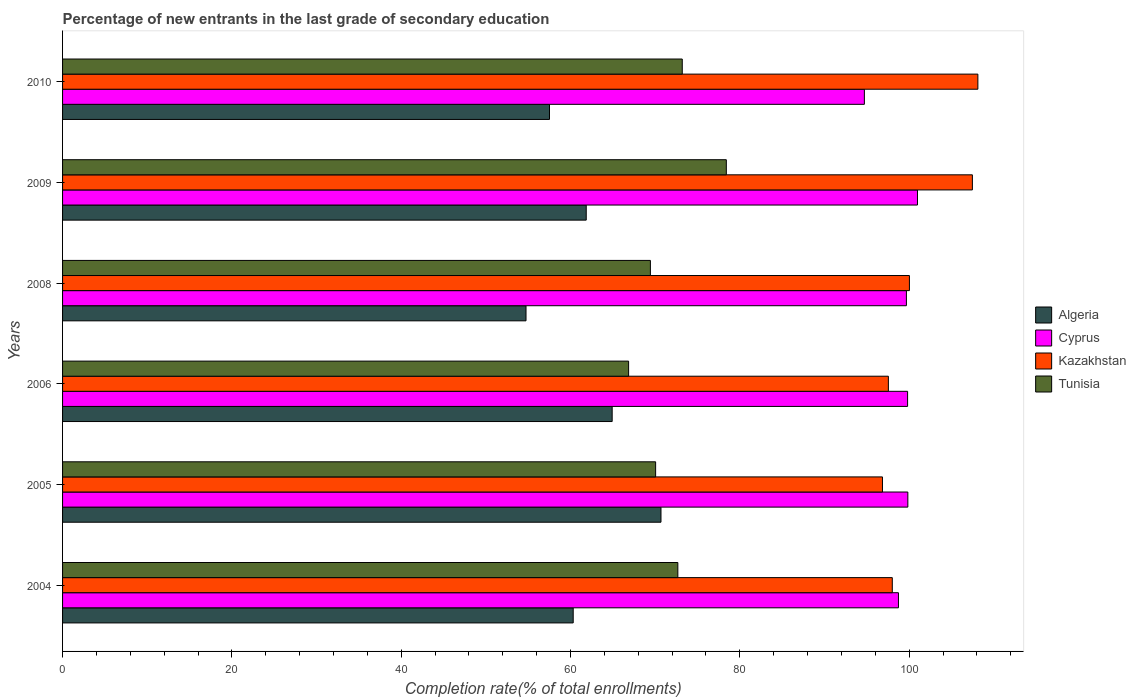How many different coloured bars are there?
Keep it short and to the point. 4. How many groups of bars are there?
Ensure brevity in your answer.  6. How many bars are there on the 6th tick from the top?
Offer a terse response. 4. What is the label of the 2nd group of bars from the top?
Your response must be concise. 2009. In how many cases, is the number of bars for a given year not equal to the number of legend labels?
Give a very brief answer. 0. What is the percentage of new entrants in Tunisia in 2009?
Your response must be concise. 78.41. Across all years, what is the maximum percentage of new entrants in Kazakhstan?
Give a very brief answer. 108.12. Across all years, what is the minimum percentage of new entrants in Kazakhstan?
Offer a terse response. 96.85. In which year was the percentage of new entrants in Kazakhstan maximum?
Ensure brevity in your answer.  2010. In which year was the percentage of new entrants in Tunisia minimum?
Offer a terse response. 2006. What is the total percentage of new entrants in Kazakhstan in the graph?
Your answer should be compact. 608.02. What is the difference between the percentage of new entrants in Algeria in 2005 and that in 2009?
Provide a short and direct response. 8.83. What is the difference between the percentage of new entrants in Tunisia in 2009 and the percentage of new entrants in Algeria in 2008?
Provide a short and direct response. 23.66. What is the average percentage of new entrants in Kazakhstan per year?
Keep it short and to the point. 101.34. In the year 2009, what is the difference between the percentage of new entrants in Kazakhstan and percentage of new entrants in Cyprus?
Provide a short and direct response. 6.49. What is the ratio of the percentage of new entrants in Kazakhstan in 2006 to that in 2010?
Give a very brief answer. 0.9. What is the difference between the highest and the second highest percentage of new entrants in Kazakhstan?
Keep it short and to the point. 0.65. What is the difference between the highest and the lowest percentage of new entrants in Algeria?
Offer a very short reply. 15.94. Is the sum of the percentage of new entrants in Kazakhstan in 2005 and 2009 greater than the maximum percentage of new entrants in Algeria across all years?
Keep it short and to the point. Yes. What does the 2nd bar from the top in 2005 represents?
Give a very brief answer. Kazakhstan. What does the 2nd bar from the bottom in 2004 represents?
Offer a terse response. Cyprus. Is it the case that in every year, the sum of the percentage of new entrants in Cyprus and percentage of new entrants in Algeria is greater than the percentage of new entrants in Tunisia?
Offer a terse response. Yes. How many bars are there?
Give a very brief answer. 24. Are all the bars in the graph horizontal?
Your answer should be compact. Yes. How many years are there in the graph?
Keep it short and to the point. 6. What is the difference between two consecutive major ticks on the X-axis?
Provide a short and direct response. 20. Does the graph contain grids?
Keep it short and to the point. No. How are the legend labels stacked?
Make the answer very short. Vertical. What is the title of the graph?
Offer a terse response. Percentage of new entrants in the last grade of secondary education. What is the label or title of the X-axis?
Keep it short and to the point. Completion rate(% of total enrollments). What is the label or title of the Y-axis?
Your answer should be very brief. Years. What is the Completion rate(% of total enrollments) in Algeria in 2004?
Keep it short and to the point. 60.32. What is the Completion rate(% of total enrollments) of Cyprus in 2004?
Your answer should be very brief. 98.74. What is the Completion rate(% of total enrollments) in Kazakhstan in 2004?
Give a very brief answer. 98.01. What is the Completion rate(% of total enrollments) in Tunisia in 2004?
Give a very brief answer. 72.68. What is the Completion rate(% of total enrollments) in Algeria in 2005?
Provide a short and direct response. 70.69. What is the Completion rate(% of total enrollments) in Cyprus in 2005?
Give a very brief answer. 99.84. What is the Completion rate(% of total enrollments) in Kazakhstan in 2005?
Keep it short and to the point. 96.85. What is the Completion rate(% of total enrollments) of Tunisia in 2005?
Provide a short and direct response. 70.05. What is the Completion rate(% of total enrollments) of Algeria in 2006?
Provide a short and direct response. 64.92. What is the Completion rate(% of total enrollments) of Cyprus in 2006?
Provide a succinct answer. 99.82. What is the Completion rate(% of total enrollments) of Kazakhstan in 2006?
Offer a terse response. 97.55. What is the Completion rate(% of total enrollments) of Tunisia in 2006?
Make the answer very short. 66.86. What is the Completion rate(% of total enrollments) of Algeria in 2008?
Offer a very short reply. 54.74. What is the Completion rate(% of total enrollments) of Cyprus in 2008?
Provide a succinct answer. 99.68. What is the Completion rate(% of total enrollments) of Kazakhstan in 2008?
Keep it short and to the point. 100.03. What is the Completion rate(% of total enrollments) of Tunisia in 2008?
Make the answer very short. 69.44. What is the Completion rate(% of total enrollments) in Algeria in 2009?
Provide a short and direct response. 61.86. What is the Completion rate(% of total enrollments) in Cyprus in 2009?
Provide a short and direct response. 100.98. What is the Completion rate(% of total enrollments) of Kazakhstan in 2009?
Your answer should be compact. 107.47. What is the Completion rate(% of total enrollments) of Tunisia in 2009?
Give a very brief answer. 78.41. What is the Completion rate(% of total enrollments) in Algeria in 2010?
Your answer should be compact. 57.52. What is the Completion rate(% of total enrollments) in Cyprus in 2010?
Your answer should be compact. 94.71. What is the Completion rate(% of total enrollments) in Kazakhstan in 2010?
Offer a terse response. 108.12. What is the Completion rate(% of total enrollments) in Tunisia in 2010?
Your response must be concise. 73.2. Across all years, what is the maximum Completion rate(% of total enrollments) in Algeria?
Offer a very short reply. 70.69. Across all years, what is the maximum Completion rate(% of total enrollments) of Cyprus?
Your response must be concise. 100.98. Across all years, what is the maximum Completion rate(% of total enrollments) in Kazakhstan?
Your answer should be compact. 108.12. Across all years, what is the maximum Completion rate(% of total enrollments) in Tunisia?
Ensure brevity in your answer.  78.41. Across all years, what is the minimum Completion rate(% of total enrollments) of Algeria?
Ensure brevity in your answer.  54.74. Across all years, what is the minimum Completion rate(% of total enrollments) in Cyprus?
Your response must be concise. 94.71. Across all years, what is the minimum Completion rate(% of total enrollments) in Kazakhstan?
Provide a short and direct response. 96.85. Across all years, what is the minimum Completion rate(% of total enrollments) in Tunisia?
Your response must be concise. 66.86. What is the total Completion rate(% of total enrollments) of Algeria in the graph?
Keep it short and to the point. 370.04. What is the total Completion rate(% of total enrollments) in Cyprus in the graph?
Offer a terse response. 593.77. What is the total Completion rate(% of total enrollments) in Kazakhstan in the graph?
Ensure brevity in your answer.  608.02. What is the total Completion rate(% of total enrollments) of Tunisia in the graph?
Your answer should be very brief. 430.63. What is the difference between the Completion rate(% of total enrollments) of Algeria in 2004 and that in 2005?
Offer a terse response. -10.37. What is the difference between the Completion rate(% of total enrollments) in Cyprus in 2004 and that in 2005?
Provide a short and direct response. -1.11. What is the difference between the Completion rate(% of total enrollments) in Kazakhstan in 2004 and that in 2005?
Ensure brevity in your answer.  1.16. What is the difference between the Completion rate(% of total enrollments) of Tunisia in 2004 and that in 2005?
Your response must be concise. 2.63. What is the difference between the Completion rate(% of total enrollments) of Algeria in 2004 and that in 2006?
Your answer should be very brief. -4.6. What is the difference between the Completion rate(% of total enrollments) in Cyprus in 2004 and that in 2006?
Offer a very short reply. -1.08. What is the difference between the Completion rate(% of total enrollments) of Kazakhstan in 2004 and that in 2006?
Ensure brevity in your answer.  0.46. What is the difference between the Completion rate(% of total enrollments) in Tunisia in 2004 and that in 2006?
Give a very brief answer. 5.82. What is the difference between the Completion rate(% of total enrollments) in Algeria in 2004 and that in 2008?
Make the answer very short. 5.57. What is the difference between the Completion rate(% of total enrollments) in Cyprus in 2004 and that in 2008?
Offer a terse response. -0.94. What is the difference between the Completion rate(% of total enrollments) in Kazakhstan in 2004 and that in 2008?
Offer a very short reply. -2.02. What is the difference between the Completion rate(% of total enrollments) of Tunisia in 2004 and that in 2008?
Provide a succinct answer. 3.24. What is the difference between the Completion rate(% of total enrollments) of Algeria in 2004 and that in 2009?
Your response must be concise. -1.54. What is the difference between the Completion rate(% of total enrollments) of Cyprus in 2004 and that in 2009?
Make the answer very short. -2.25. What is the difference between the Completion rate(% of total enrollments) in Kazakhstan in 2004 and that in 2009?
Offer a terse response. -9.46. What is the difference between the Completion rate(% of total enrollments) of Tunisia in 2004 and that in 2009?
Provide a succinct answer. -5.73. What is the difference between the Completion rate(% of total enrollments) of Algeria in 2004 and that in 2010?
Offer a terse response. 2.8. What is the difference between the Completion rate(% of total enrollments) in Cyprus in 2004 and that in 2010?
Give a very brief answer. 4.03. What is the difference between the Completion rate(% of total enrollments) in Kazakhstan in 2004 and that in 2010?
Your answer should be compact. -10.11. What is the difference between the Completion rate(% of total enrollments) in Tunisia in 2004 and that in 2010?
Offer a terse response. -0.52. What is the difference between the Completion rate(% of total enrollments) in Algeria in 2005 and that in 2006?
Provide a short and direct response. 5.76. What is the difference between the Completion rate(% of total enrollments) of Cyprus in 2005 and that in 2006?
Offer a terse response. 0.03. What is the difference between the Completion rate(% of total enrollments) of Kazakhstan in 2005 and that in 2006?
Give a very brief answer. -0.7. What is the difference between the Completion rate(% of total enrollments) of Tunisia in 2005 and that in 2006?
Ensure brevity in your answer.  3.19. What is the difference between the Completion rate(% of total enrollments) in Algeria in 2005 and that in 2008?
Your response must be concise. 15.94. What is the difference between the Completion rate(% of total enrollments) in Cyprus in 2005 and that in 2008?
Make the answer very short. 0.17. What is the difference between the Completion rate(% of total enrollments) in Kazakhstan in 2005 and that in 2008?
Ensure brevity in your answer.  -3.18. What is the difference between the Completion rate(% of total enrollments) in Tunisia in 2005 and that in 2008?
Offer a terse response. 0.62. What is the difference between the Completion rate(% of total enrollments) in Algeria in 2005 and that in 2009?
Offer a terse response. 8.83. What is the difference between the Completion rate(% of total enrollments) of Cyprus in 2005 and that in 2009?
Your answer should be very brief. -1.14. What is the difference between the Completion rate(% of total enrollments) in Kazakhstan in 2005 and that in 2009?
Ensure brevity in your answer.  -10.62. What is the difference between the Completion rate(% of total enrollments) in Tunisia in 2005 and that in 2009?
Keep it short and to the point. -8.35. What is the difference between the Completion rate(% of total enrollments) of Algeria in 2005 and that in 2010?
Give a very brief answer. 13.17. What is the difference between the Completion rate(% of total enrollments) in Cyprus in 2005 and that in 2010?
Keep it short and to the point. 5.13. What is the difference between the Completion rate(% of total enrollments) in Kazakhstan in 2005 and that in 2010?
Provide a short and direct response. -11.27. What is the difference between the Completion rate(% of total enrollments) in Tunisia in 2005 and that in 2010?
Offer a very short reply. -3.15. What is the difference between the Completion rate(% of total enrollments) in Algeria in 2006 and that in 2008?
Your answer should be very brief. 10.18. What is the difference between the Completion rate(% of total enrollments) of Cyprus in 2006 and that in 2008?
Make the answer very short. 0.14. What is the difference between the Completion rate(% of total enrollments) in Kazakhstan in 2006 and that in 2008?
Provide a succinct answer. -2.49. What is the difference between the Completion rate(% of total enrollments) in Tunisia in 2006 and that in 2008?
Your answer should be very brief. -2.57. What is the difference between the Completion rate(% of total enrollments) of Algeria in 2006 and that in 2009?
Keep it short and to the point. 3.06. What is the difference between the Completion rate(% of total enrollments) of Cyprus in 2006 and that in 2009?
Keep it short and to the point. -1.17. What is the difference between the Completion rate(% of total enrollments) of Kazakhstan in 2006 and that in 2009?
Keep it short and to the point. -9.92. What is the difference between the Completion rate(% of total enrollments) in Tunisia in 2006 and that in 2009?
Your response must be concise. -11.54. What is the difference between the Completion rate(% of total enrollments) of Algeria in 2006 and that in 2010?
Offer a terse response. 7.4. What is the difference between the Completion rate(% of total enrollments) in Cyprus in 2006 and that in 2010?
Keep it short and to the point. 5.11. What is the difference between the Completion rate(% of total enrollments) in Kazakhstan in 2006 and that in 2010?
Provide a succinct answer. -10.57. What is the difference between the Completion rate(% of total enrollments) of Tunisia in 2006 and that in 2010?
Give a very brief answer. -6.34. What is the difference between the Completion rate(% of total enrollments) in Algeria in 2008 and that in 2009?
Keep it short and to the point. -7.11. What is the difference between the Completion rate(% of total enrollments) of Cyprus in 2008 and that in 2009?
Offer a terse response. -1.31. What is the difference between the Completion rate(% of total enrollments) in Kazakhstan in 2008 and that in 2009?
Offer a very short reply. -7.44. What is the difference between the Completion rate(% of total enrollments) of Tunisia in 2008 and that in 2009?
Keep it short and to the point. -8.97. What is the difference between the Completion rate(% of total enrollments) in Algeria in 2008 and that in 2010?
Offer a very short reply. -2.77. What is the difference between the Completion rate(% of total enrollments) of Cyprus in 2008 and that in 2010?
Give a very brief answer. 4.96. What is the difference between the Completion rate(% of total enrollments) of Kazakhstan in 2008 and that in 2010?
Your answer should be compact. -8.09. What is the difference between the Completion rate(% of total enrollments) of Tunisia in 2008 and that in 2010?
Your response must be concise. -3.76. What is the difference between the Completion rate(% of total enrollments) in Algeria in 2009 and that in 2010?
Give a very brief answer. 4.34. What is the difference between the Completion rate(% of total enrollments) of Cyprus in 2009 and that in 2010?
Provide a short and direct response. 6.27. What is the difference between the Completion rate(% of total enrollments) of Kazakhstan in 2009 and that in 2010?
Your response must be concise. -0.65. What is the difference between the Completion rate(% of total enrollments) in Tunisia in 2009 and that in 2010?
Make the answer very short. 5.21. What is the difference between the Completion rate(% of total enrollments) in Algeria in 2004 and the Completion rate(% of total enrollments) in Cyprus in 2005?
Provide a succinct answer. -39.53. What is the difference between the Completion rate(% of total enrollments) of Algeria in 2004 and the Completion rate(% of total enrollments) of Kazakhstan in 2005?
Make the answer very short. -36.53. What is the difference between the Completion rate(% of total enrollments) of Algeria in 2004 and the Completion rate(% of total enrollments) of Tunisia in 2005?
Give a very brief answer. -9.74. What is the difference between the Completion rate(% of total enrollments) in Cyprus in 2004 and the Completion rate(% of total enrollments) in Kazakhstan in 2005?
Ensure brevity in your answer.  1.89. What is the difference between the Completion rate(% of total enrollments) of Cyprus in 2004 and the Completion rate(% of total enrollments) of Tunisia in 2005?
Your answer should be compact. 28.68. What is the difference between the Completion rate(% of total enrollments) in Kazakhstan in 2004 and the Completion rate(% of total enrollments) in Tunisia in 2005?
Provide a short and direct response. 27.96. What is the difference between the Completion rate(% of total enrollments) in Algeria in 2004 and the Completion rate(% of total enrollments) in Cyprus in 2006?
Offer a terse response. -39.5. What is the difference between the Completion rate(% of total enrollments) of Algeria in 2004 and the Completion rate(% of total enrollments) of Kazakhstan in 2006?
Make the answer very short. -37.23. What is the difference between the Completion rate(% of total enrollments) in Algeria in 2004 and the Completion rate(% of total enrollments) in Tunisia in 2006?
Offer a terse response. -6.54. What is the difference between the Completion rate(% of total enrollments) of Cyprus in 2004 and the Completion rate(% of total enrollments) of Kazakhstan in 2006?
Give a very brief answer. 1.19. What is the difference between the Completion rate(% of total enrollments) in Cyprus in 2004 and the Completion rate(% of total enrollments) in Tunisia in 2006?
Ensure brevity in your answer.  31.88. What is the difference between the Completion rate(% of total enrollments) of Kazakhstan in 2004 and the Completion rate(% of total enrollments) of Tunisia in 2006?
Your answer should be compact. 31.15. What is the difference between the Completion rate(% of total enrollments) in Algeria in 2004 and the Completion rate(% of total enrollments) in Cyprus in 2008?
Provide a succinct answer. -39.36. What is the difference between the Completion rate(% of total enrollments) of Algeria in 2004 and the Completion rate(% of total enrollments) of Kazakhstan in 2008?
Provide a short and direct response. -39.71. What is the difference between the Completion rate(% of total enrollments) in Algeria in 2004 and the Completion rate(% of total enrollments) in Tunisia in 2008?
Give a very brief answer. -9.12. What is the difference between the Completion rate(% of total enrollments) of Cyprus in 2004 and the Completion rate(% of total enrollments) of Kazakhstan in 2008?
Provide a short and direct response. -1.29. What is the difference between the Completion rate(% of total enrollments) of Cyprus in 2004 and the Completion rate(% of total enrollments) of Tunisia in 2008?
Make the answer very short. 29.3. What is the difference between the Completion rate(% of total enrollments) of Kazakhstan in 2004 and the Completion rate(% of total enrollments) of Tunisia in 2008?
Offer a very short reply. 28.57. What is the difference between the Completion rate(% of total enrollments) in Algeria in 2004 and the Completion rate(% of total enrollments) in Cyprus in 2009?
Your response must be concise. -40.67. What is the difference between the Completion rate(% of total enrollments) in Algeria in 2004 and the Completion rate(% of total enrollments) in Kazakhstan in 2009?
Make the answer very short. -47.15. What is the difference between the Completion rate(% of total enrollments) in Algeria in 2004 and the Completion rate(% of total enrollments) in Tunisia in 2009?
Your answer should be compact. -18.09. What is the difference between the Completion rate(% of total enrollments) in Cyprus in 2004 and the Completion rate(% of total enrollments) in Kazakhstan in 2009?
Give a very brief answer. -8.73. What is the difference between the Completion rate(% of total enrollments) of Cyprus in 2004 and the Completion rate(% of total enrollments) of Tunisia in 2009?
Keep it short and to the point. 20.33. What is the difference between the Completion rate(% of total enrollments) of Kazakhstan in 2004 and the Completion rate(% of total enrollments) of Tunisia in 2009?
Give a very brief answer. 19.6. What is the difference between the Completion rate(% of total enrollments) of Algeria in 2004 and the Completion rate(% of total enrollments) of Cyprus in 2010?
Ensure brevity in your answer.  -34.39. What is the difference between the Completion rate(% of total enrollments) of Algeria in 2004 and the Completion rate(% of total enrollments) of Kazakhstan in 2010?
Provide a short and direct response. -47.8. What is the difference between the Completion rate(% of total enrollments) in Algeria in 2004 and the Completion rate(% of total enrollments) in Tunisia in 2010?
Offer a terse response. -12.88. What is the difference between the Completion rate(% of total enrollments) of Cyprus in 2004 and the Completion rate(% of total enrollments) of Kazakhstan in 2010?
Make the answer very short. -9.38. What is the difference between the Completion rate(% of total enrollments) of Cyprus in 2004 and the Completion rate(% of total enrollments) of Tunisia in 2010?
Offer a very short reply. 25.54. What is the difference between the Completion rate(% of total enrollments) of Kazakhstan in 2004 and the Completion rate(% of total enrollments) of Tunisia in 2010?
Provide a succinct answer. 24.81. What is the difference between the Completion rate(% of total enrollments) in Algeria in 2005 and the Completion rate(% of total enrollments) in Cyprus in 2006?
Ensure brevity in your answer.  -29.13. What is the difference between the Completion rate(% of total enrollments) in Algeria in 2005 and the Completion rate(% of total enrollments) in Kazakhstan in 2006?
Make the answer very short. -26.86. What is the difference between the Completion rate(% of total enrollments) of Algeria in 2005 and the Completion rate(% of total enrollments) of Tunisia in 2006?
Your answer should be very brief. 3.82. What is the difference between the Completion rate(% of total enrollments) of Cyprus in 2005 and the Completion rate(% of total enrollments) of Kazakhstan in 2006?
Provide a short and direct response. 2.3. What is the difference between the Completion rate(% of total enrollments) of Cyprus in 2005 and the Completion rate(% of total enrollments) of Tunisia in 2006?
Your answer should be compact. 32.98. What is the difference between the Completion rate(% of total enrollments) of Kazakhstan in 2005 and the Completion rate(% of total enrollments) of Tunisia in 2006?
Your answer should be compact. 29.99. What is the difference between the Completion rate(% of total enrollments) of Algeria in 2005 and the Completion rate(% of total enrollments) of Cyprus in 2008?
Make the answer very short. -28.99. What is the difference between the Completion rate(% of total enrollments) of Algeria in 2005 and the Completion rate(% of total enrollments) of Kazakhstan in 2008?
Keep it short and to the point. -29.35. What is the difference between the Completion rate(% of total enrollments) of Algeria in 2005 and the Completion rate(% of total enrollments) of Tunisia in 2008?
Make the answer very short. 1.25. What is the difference between the Completion rate(% of total enrollments) in Cyprus in 2005 and the Completion rate(% of total enrollments) in Kazakhstan in 2008?
Offer a terse response. -0.19. What is the difference between the Completion rate(% of total enrollments) of Cyprus in 2005 and the Completion rate(% of total enrollments) of Tunisia in 2008?
Your answer should be compact. 30.41. What is the difference between the Completion rate(% of total enrollments) in Kazakhstan in 2005 and the Completion rate(% of total enrollments) in Tunisia in 2008?
Make the answer very short. 27.41. What is the difference between the Completion rate(% of total enrollments) in Algeria in 2005 and the Completion rate(% of total enrollments) in Cyprus in 2009?
Ensure brevity in your answer.  -30.3. What is the difference between the Completion rate(% of total enrollments) of Algeria in 2005 and the Completion rate(% of total enrollments) of Kazakhstan in 2009?
Make the answer very short. -36.78. What is the difference between the Completion rate(% of total enrollments) of Algeria in 2005 and the Completion rate(% of total enrollments) of Tunisia in 2009?
Offer a terse response. -7.72. What is the difference between the Completion rate(% of total enrollments) in Cyprus in 2005 and the Completion rate(% of total enrollments) in Kazakhstan in 2009?
Provide a short and direct response. -7.62. What is the difference between the Completion rate(% of total enrollments) of Cyprus in 2005 and the Completion rate(% of total enrollments) of Tunisia in 2009?
Give a very brief answer. 21.44. What is the difference between the Completion rate(% of total enrollments) in Kazakhstan in 2005 and the Completion rate(% of total enrollments) in Tunisia in 2009?
Offer a terse response. 18.44. What is the difference between the Completion rate(% of total enrollments) of Algeria in 2005 and the Completion rate(% of total enrollments) of Cyprus in 2010?
Offer a terse response. -24.03. What is the difference between the Completion rate(% of total enrollments) of Algeria in 2005 and the Completion rate(% of total enrollments) of Kazakhstan in 2010?
Keep it short and to the point. -37.43. What is the difference between the Completion rate(% of total enrollments) of Algeria in 2005 and the Completion rate(% of total enrollments) of Tunisia in 2010?
Give a very brief answer. -2.51. What is the difference between the Completion rate(% of total enrollments) of Cyprus in 2005 and the Completion rate(% of total enrollments) of Kazakhstan in 2010?
Keep it short and to the point. -8.27. What is the difference between the Completion rate(% of total enrollments) in Cyprus in 2005 and the Completion rate(% of total enrollments) in Tunisia in 2010?
Your answer should be compact. 26.64. What is the difference between the Completion rate(% of total enrollments) in Kazakhstan in 2005 and the Completion rate(% of total enrollments) in Tunisia in 2010?
Your answer should be compact. 23.65. What is the difference between the Completion rate(% of total enrollments) in Algeria in 2006 and the Completion rate(% of total enrollments) in Cyprus in 2008?
Keep it short and to the point. -34.75. What is the difference between the Completion rate(% of total enrollments) of Algeria in 2006 and the Completion rate(% of total enrollments) of Kazakhstan in 2008?
Ensure brevity in your answer.  -35.11. What is the difference between the Completion rate(% of total enrollments) in Algeria in 2006 and the Completion rate(% of total enrollments) in Tunisia in 2008?
Your answer should be very brief. -4.51. What is the difference between the Completion rate(% of total enrollments) of Cyprus in 2006 and the Completion rate(% of total enrollments) of Kazakhstan in 2008?
Your answer should be very brief. -0.21. What is the difference between the Completion rate(% of total enrollments) in Cyprus in 2006 and the Completion rate(% of total enrollments) in Tunisia in 2008?
Give a very brief answer. 30.38. What is the difference between the Completion rate(% of total enrollments) of Kazakhstan in 2006 and the Completion rate(% of total enrollments) of Tunisia in 2008?
Offer a terse response. 28.11. What is the difference between the Completion rate(% of total enrollments) in Algeria in 2006 and the Completion rate(% of total enrollments) in Cyprus in 2009?
Give a very brief answer. -36.06. What is the difference between the Completion rate(% of total enrollments) in Algeria in 2006 and the Completion rate(% of total enrollments) in Kazakhstan in 2009?
Keep it short and to the point. -42.55. What is the difference between the Completion rate(% of total enrollments) in Algeria in 2006 and the Completion rate(% of total enrollments) in Tunisia in 2009?
Make the answer very short. -13.48. What is the difference between the Completion rate(% of total enrollments) in Cyprus in 2006 and the Completion rate(% of total enrollments) in Kazakhstan in 2009?
Ensure brevity in your answer.  -7.65. What is the difference between the Completion rate(% of total enrollments) in Cyprus in 2006 and the Completion rate(% of total enrollments) in Tunisia in 2009?
Provide a short and direct response. 21.41. What is the difference between the Completion rate(% of total enrollments) in Kazakhstan in 2006 and the Completion rate(% of total enrollments) in Tunisia in 2009?
Your response must be concise. 19.14. What is the difference between the Completion rate(% of total enrollments) of Algeria in 2006 and the Completion rate(% of total enrollments) of Cyprus in 2010?
Ensure brevity in your answer.  -29.79. What is the difference between the Completion rate(% of total enrollments) in Algeria in 2006 and the Completion rate(% of total enrollments) in Kazakhstan in 2010?
Your answer should be very brief. -43.2. What is the difference between the Completion rate(% of total enrollments) in Algeria in 2006 and the Completion rate(% of total enrollments) in Tunisia in 2010?
Make the answer very short. -8.28. What is the difference between the Completion rate(% of total enrollments) of Cyprus in 2006 and the Completion rate(% of total enrollments) of Kazakhstan in 2010?
Keep it short and to the point. -8.3. What is the difference between the Completion rate(% of total enrollments) in Cyprus in 2006 and the Completion rate(% of total enrollments) in Tunisia in 2010?
Your answer should be very brief. 26.62. What is the difference between the Completion rate(% of total enrollments) of Kazakhstan in 2006 and the Completion rate(% of total enrollments) of Tunisia in 2010?
Ensure brevity in your answer.  24.35. What is the difference between the Completion rate(% of total enrollments) of Algeria in 2008 and the Completion rate(% of total enrollments) of Cyprus in 2009?
Offer a very short reply. -46.24. What is the difference between the Completion rate(% of total enrollments) of Algeria in 2008 and the Completion rate(% of total enrollments) of Kazakhstan in 2009?
Offer a terse response. -52.73. What is the difference between the Completion rate(% of total enrollments) of Algeria in 2008 and the Completion rate(% of total enrollments) of Tunisia in 2009?
Your answer should be very brief. -23.66. What is the difference between the Completion rate(% of total enrollments) of Cyprus in 2008 and the Completion rate(% of total enrollments) of Kazakhstan in 2009?
Make the answer very short. -7.79. What is the difference between the Completion rate(% of total enrollments) in Cyprus in 2008 and the Completion rate(% of total enrollments) in Tunisia in 2009?
Provide a succinct answer. 21.27. What is the difference between the Completion rate(% of total enrollments) of Kazakhstan in 2008 and the Completion rate(% of total enrollments) of Tunisia in 2009?
Keep it short and to the point. 21.63. What is the difference between the Completion rate(% of total enrollments) in Algeria in 2008 and the Completion rate(% of total enrollments) in Cyprus in 2010?
Provide a succinct answer. -39.97. What is the difference between the Completion rate(% of total enrollments) of Algeria in 2008 and the Completion rate(% of total enrollments) of Kazakhstan in 2010?
Keep it short and to the point. -53.37. What is the difference between the Completion rate(% of total enrollments) in Algeria in 2008 and the Completion rate(% of total enrollments) in Tunisia in 2010?
Offer a very short reply. -18.46. What is the difference between the Completion rate(% of total enrollments) in Cyprus in 2008 and the Completion rate(% of total enrollments) in Kazakhstan in 2010?
Ensure brevity in your answer.  -8.44. What is the difference between the Completion rate(% of total enrollments) of Cyprus in 2008 and the Completion rate(% of total enrollments) of Tunisia in 2010?
Provide a succinct answer. 26.48. What is the difference between the Completion rate(% of total enrollments) of Kazakhstan in 2008 and the Completion rate(% of total enrollments) of Tunisia in 2010?
Your response must be concise. 26.83. What is the difference between the Completion rate(% of total enrollments) in Algeria in 2009 and the Completion rate(% of total enrollments) in Cyprus in 2010?
Keep it short and to the point. -32.85. What is the difference between the Completion rate(% of total enrollments) of Algeria in 2009 and the Completion rate(% of total enrollments) of Kazakhstan in 2010?
Your response must be concise. -46.26. What is the difference between the Completion rate(% of total enrollments) of Algeria in 2009 and the Completion rate(% of total enrollments) of Tunisia in 2010?
Make the answer very short. -11.34. What is the difference between the Completion rate(% of total enrollments) of Cyprus in 2009 and the Completion rate(% of total enrollments) of Kazakhstan in 2010?
Give a very brief answer. -7.13. What is the difference between the Completion rate(% of total enrollments) in Cyprus in 2009 and the Completion rate(% of total enrollments) in Tunisia in 2010?
Provide a short and direct response. 27.78. What is the difference between the Completion rate(% of total enrollments) of Kazakhstan in 2009 and the Completion rate(% of total enrollments) of Tunisia in 2010?
Your response must be concise. 34.27. What is the average Completion rate(% of total enrollments) in Algeria per year?
Provide a succinct answer. 61.67. What is the average Completion rate(% of total enrollments) in Cyprus per year?
Make the answer very short. 98.96. What is the average Completion rate(% of total enrollments) of Kazakhstan per year?
Ensure brevity in your answer.  101.34. What is the average Completion rate(% of total enrollments) of Tunisia per year?
Ensure brevity in your answer.  71.77. In the year 2004, what is the difference between the Completion rate(% of total enrollments) of Algeria and Completion rate(% of total enrollments) of Cyprus?
Your response must be concise. -38.42. In the year 2004, what is the difference between the Completion rate(% of total enrollments) in Algeria and Completion rate(% of total enrollments) in Kazakhstan?
Ensure brevity in your answer.  -37.69. In the year 2004, what is the difference between the Completion rate(% of total enrollments) of Algeria and Completion rate(% of total enrollments) of Tunisia?
Offer a very short reply. -12.36. In the year 2004, what is the difference between the Completion rate(% of total enrollments) in Cyprus and Completion rate(% of total enrollments) in Kazakhstan?
Provide a short and direct response. 0.73. In the year 2004, what is the difference between the Completion rate(% of total enrollments) of Cyprus and Completion rate(% of total enrollments) of Tunisia?
Your response must be concise. 26.06. In the year 2004, what is the difference between the Completion rate(% of total enrollments) of Kazakhstan and Completion rate(% of total enrollments) of Tunisia?
Make the answer very short. 25.33. In the year 2005, what is the difference between the Completion rate(% of total enrollments) of Algeria and Completion rate(% of total enrollments) of Cyprus?
Offer a very short reply. -29.16. In the year 2005, what is the difference between the Completion rate(% of total enrollments) of Algeria and Completion rate(% of total enrollments) of Kazakhstan?
Make the answer very short. -26.16. In the year 2005, what is the difference between the Completion rate(% of total enrollments) of Algeria and Completion rate(% of total enrollments) of Tunisia?
Your response must be concise. 0.63. In the year 2005, what is the difference between the Completion rate(% of total enrollments) in Cyprus and Completion rate(% of total enrollments) in Kazakhstan?
Keep it short and to the point. 3. In the year 2005, what is the difference between the Completion rate(% of total enrollments) in Cyprus and Completion rate(% of total enrollments) in Tunisia?
Provide a short and direct response. 29.79. In the year 2005, what is the difference between the Completion rate(% of total enrollments) in Kazakhstan and Completion rate(% of total enrollments) in Tunisia?
Your response must be concise. 26.8. In the year 2006, what is the difference between the Completion rate(% of total enrollments) of Algeria and Completion rate(% of total enrollments) of Cyprus?
Make the answer very short. -34.9. In the year 2006, what is the difference between the Completion rate(% of total enrollments) in Algeria and Completion rate(% of total enrollments) in Kazakhstan?
Make the answer very short. -32.62. In the year 2006, what is the difference between the Completion rate(% of total enrollments) in Algeria and Completion rate(% of total enrollments) in Tunisia?
Ensure brevity in your answer.  -1.94. In the year 2006, what is the difference between the Completion rate(% of total enrollments) in Cyprus and Completion rate(% of total enrollments) in Kazakhstan?
Ensure brevity in your answer.  2.27. In the year 2006, what is the difference between the Completion rate(% of total enrollments) of Cyprus and Completion rate(% of total enrollments) of Tunisia?
Offer a terse response. 32.95. In the year 2006, what is the difference between the Completion rate(% of total enrollments) of Kazakhstan and Completion rate(% of total enrollments) of Tunisia?
Ensure brevity in your answer.  30.68. In the year 2008, what is the difference between the Completion rate(% of total enrollments) of Algeria and Completion rate(% of total enrollments) of Cyprus?
Offer a very short reply. -44.93. In the year 2008, what is the difference between the Completion rate(% of total enrollments) of Algeria and Completion rate(% of total enrollments) of Kazakhstan?
Your answer should be very brief. -45.29. In the year 2008, what is the difference between the Completion rate(% of total enrollments) in Algeria and Completion rate(% of total enrollments) in Tunisia?
Your response must be concise. -14.69. In the year 2008, what is the difference between the Completion rate(% of total enrollments) in Cyprus and Completion rate(% of total enrollments) in Kazakhstan?
Provide a short and direct response. -0.36. In the year 2008, what is the difference between the Completion rate(% of total enrollments) in Cyprus and Completion rate(% of total enrollments) in Tunisia?
Offer a terse response. 30.24. In the year 2008, what is the difference between the Completion rate(% of total enrollments) in Kazakhstan and Completion rate(% of total enrollments) in Tunisia?
Offer a terse response. 30.6. In the year 2009, what is the difference between the Completion rate(% of total enrollments) of Algeria and Completion rate(% of total enrollments) of Cyprus?
Your answer should be very brief. -39.13. In the year 2009, what is the difference between the Completion rate(% of total enrollments) in Algeria and Completion rate(% of total enrollments) in Kazakhstan?
Provide a short and direct response. -45.61. In the year 2009, what is the difference between the Completion rate(% of total enrollments) of Algeria and Completion rate(% of total enrollments) of Tunisia?
Offer a very short reply. -16.55. In the year 2009, what is the difference between the Completion rate(% of total enrollments) in Cyprus and Completion rate(% of total enrollments) in Kazakhstan?
Offer a very short reply. -6.49. In the year 2009, what is the difference between the Completion rate(% of total enrollments) in Cyprus and Completion rate(% of total enrollments) in Tunisia?
Make the answer very short. 22.58. In the year 2009, what is the difference between the Completion rate(% of total enrollments) of Kazakhstan and Completion rate(% of total enrollments) of Tunisia?
Your answer should be compact. 29.06. In the year 2010, what is the difference between the Completion rate(% of total enrollments) of Algeria and Completion rate(% of total enrollments) of Cyprus?
Provide a short and direct response. -37.19. In the year 2010, what is the difference between the Completion rate(% of total enrollments) of Algeria and Completion rate(% of total enrollments) of Kazakhstan?
Offer a very short reply. -50.6. In the year 2010, what is the difference between the Completion rate(% of total enrollments) in Algeria and Completion rate(% of total enrollments) in Tunisia?
Provide a succinct answer. -15.68. In the year 2010, what is the difference between the Completion rate(% of total enrollments) of Cyprus and Completion rate(% of total enrollments) of Kazakhstan?
Provide a short and direct response. -13.41. In the year 2010, what is the difference between the Completion rate(% of total enrollments) of Cyprus and Completion rate(% of total enrollments) of Tunisia?
Offer a very short reply. 21.51. In the year 2010, what is the difference between the Completion rate(% of total enrollments) in Kazakhstan and Completion rate(% of total enrollments) in Tunisia?
Your answer should be very brief. 34.92. What is the ratio of the Completion rate(% of total enrollments) in Algeria in 2004 to that in 2005?
Give a very brief answer. 0.85. What is the ratio of the Completion rate(% of total enrollments) in Cyprus in 2004 to that in 2005?
Keep it short and to the point. 0.99. What is the ratio of the Completion rate(% of total enrollments) in Tunisia in 2004 to that in 2005?
Make the answer very short. 1.04. What is the ratio of the Completion rate(% of total enrollments) in Algeria in 2004 to that in 2006?
Your answer should be very brief. 0.93. What is the ratio of the Completion rate(% of total enrollments) of Kazakhstan in 2004 to that in 2006?
Keep it short and to the point. 1. What is the ratio of the Completion rate(% of total enrollments) of Tunisia in 2004 to that in 2006?
Ensure brevity in your answer.  1.09. What is the ratio of the Completion rate(% of total enrollments) of Algeria in 2004 to that in 2008?
Provide a short and direct response. 1.1. What is the ratio of the Completion rate(% of total enrollments) of Cyprus in 2004 to that in 2008?
Offer a very short reply. 0.99. What is the ratio of the Completion rate(% of total enrollments) in Kazakhstan in 2004 to that in 2008?
Your answer should be compact. 0.98. What is the ratio of the Completion rate(% of total enrollments) in Tunisia in 2004 to that in 2008?
Provide a short and direct response. 1.05. What is the ratio of the Completion rate(% of total enrollments) of Algeria in 2004 to that in 2009?
Your answer should be compact. 0.98. What is the ratio of the Completion rate(% of total enrollments) in Cyprus in 2004 to that in 2009?
Offer a terse response. 0.98. What is the ratio of the Completion rate(% of total enrollments) in Kazakhstan in 2004 to that in 2009?
Offer a very short reply. 0.91. What is the ratio of the Completion rate(% of total enrollments) in Tunisia in 2004 to that in 2009?
Ensure brevity in your answer.  0.93. What is the ratio of the Completion rate(% of total enrollments) of Algeria in 2004 to that in 2010?
Provide a succinct answer. 1.05. What is the ratio of the Completion rate(% of total enrollments) in Cyprus in 2004 to that in 2010?
Give a very brief answer. 1.04. What is the ratio of the Completion rate(% of total enrollments) in Kazakhstan in 2004 to that in 2010?
Offer a very short reply. 0.91. What is the ratio of the Completion rate(% of total enrollments) in Algeria in 2005 to that in 2006?
Offer a very short reply. 1.09. What is the ratio of the Completion rate(% of total enrollments) of Cyprus in 2005 to that in 2006?
Provide a short and direct response. 1. What is the ratio of the Completion rate(% of total enrollments) of Kazakhstan in 2005 to that in 2006?
Provide a short and direct response. 0.99. What is the ratio of the Completion rate(% of total enrollments) in Tunisia in 2005 to that in 2006?
Provide a short and direct response. 1.05. What is the ratio of the Completion rate(% of total enrollments) of Algeria in 2005 to that in 2008?
Ensure brevity in your answer.  1.29. What is the ratio of the Completion rate(% of total enrollments) of Cyprus in 2005 to that in 2008?
Offer a very short reply. 1. What is the ratio of the Completion rate(% of total enrollments) of Kazakhstan in 2005 to that in 2008?
Give a very brief answer. 0.97. What is the ratio of the Completion rate(% of total enrollments) in Tunisia in 2005 to that in 2008?
Offer a very short reply. 1.01. What is the ratio of the Completion rate(% of total enrollments) of Algeria in 2005 to that in 2009?
Offer a very short reply. 1.14. What is the ratio of the Completion rate(% of total enrollments) of Cyprus in 2005 to that in 2009?
Provide a short and direct response. 0.99. What is the ratio of the Completion rate(% of total enrollments) of Kazakhstan in 2005 to that in 2009?
Provide a succinct answer. 0.9. What is the ratio of the Completion rate(% of total enrollments) in Tunisia in 2005 to that in 2009?
Your answer should be compact. 0.89. What is the ratio of the Completion rate(% of total enrollments) of Algeria in 2005 to that in 2010?
Make the answer very short. 1.23. What is the ratio of the Completion rate(% of total enrollments) of Cyprus in 2005 to that in 2010?
Your answer should be very brief. 1.05. What is the ratio of the Completion rate(% of total enrollments) of Kazakhstan in 2005 to that in 2010?
Your answer should be compact. 0.9. What is the ratio of the Completion rate(% of total enrollments) of Algeria in 2006 to that in 2008?
Make the answer very short. 1.19. What is the ratio of the Completion rate(% of total enrollments) in Kazakhstan in 2006 to that in 2008?
Offer a very short reply. 0.98. What is the ratio of the Completion rate(% of total enrollments) in Tunisia in 2006 to that in 2008?
Offer a terse response. 0.96. What is the ratio of the Completion rate(% of total enrollments) of Algeria in 2006 to that in 2009?
Your response must be concise. 1.05. What is the ratio of the Completion rate(% of total enrollments) in Cyprus in 2006 to that in 2009?
Offer a very short reply. 0.99. What is the ratio of the Completion rate(% of total enrollments) of Kazakhstan in 2006 to that in 2009?
Provide a succinct answer. 0.91. What is the ratio of the Completion rate(% of total enrollments) in Tunisia in 2006 to that in 2009?
Your answer should be very brief. 0.85. What is the ratio of the Completion rate(% of total enrollments) in Algeria in 2006 to that in 2010?
Provide a short and direct response. 1.13. What is the ratio of the Completion rate(% of total enrollments) in Cyprus in 2006 to that in 2010?
Keep it short and to the point. 1.05. What is the ratio of the Completion rate(% of total enrollments) of Kazakhstan in 2006 to that in 2010?
Your answer should be very brief. 0.9. What is the ratio of the Completion rate(% of total enrollments) in Tunisia in 2006 to that in 2010?
Your response must be concise. 0.91. What is the ratio of the Completion rate(% of total enrollments) of Algeria in 2008 to that in 2009?
Offer a terse response. 0.89. What is the ratio of the Completion rate(% of total enrollments) in Kazakhstan in 2008 to that in 2009?
Your answer should be very brief. 0.93. What is the ratio of the Completion rate(% of total enrollments) of Tunisia in 2008 to that in 2009?
Give a very brief answer. 0.89. What is the ratio of the Completion rate(% of total enrollments) of Algeria in 2008 to that in 2010?
Offer a terse response. 0.95. What is the ratio of the Completion rate(% of total enrollments) of Cyprus in 2008 to that in 2010?
Offer a terse response. 1.05. What is the ratio of the Completion rate(% of total enrollments) in Kazakhstan in 2008 to that in 2010?
Your answer should be very brief. 0.93. What is the ratio of the Completion rate(% of total enrollments) in Tunisia in 2008 to that in 2010?
Your answer should be very brief. 0.95. What is the ratio of the Completion rate(% of total enrollments) of Algeria in 2009 to that in 2010?
Your answer should be compact. 1.08. What is the ratio of the Completion rate(% of total enrollments) in Cyprus in 2009 to that in 2010?
Ensure brevity in your answer.  1.07. What is the ratio of the Completion rate(% of total enrollments) of Kazakhstan in 2009 to that in 2010?
Keep it short and to the point. 0.99. What is the ratio of the Completion rate(% of total enrollments) in Tunisia in 2009 to that in 2010?
Your response must be concise. 1.07. What is the difference between the highest and the second highest Completion rate(% of total enrollments) of Algeria?
Ensure brevity in your answer.  5.76. What is the difference between the highest and the second highest Completion rate(% of total enrollments) of Cyprus?
Keep it short and to the point. 1.14. What is the difference between the highest and the second highest Completion rate(% of total enrollments) in Kazakhstan?
Ensure brevity in your answer.  0.65. What is the difference between the highest and the second highest Completion rate(% of total enrollments) of Tunisia?
Provide a succinct answer. 5.21. What is the difference between the highest and the lowest Completion rate(% of total enrollments) of Algeria?
Offer a very short reply. 15.94. What is the difference between the highest and the lowest Completion rate(% of total enrollments) in Cyprus?
Give a very brief answer. 6.27. What is the difference between the highest and the lowest Completion rate(% of total enrollments) of Kazakhstan?
Your response must be concise. 11.27. What is the difference between the highest and the lowest Completion rate(% of total enrollments) in Tunisia?
Give a very brief answer. 11.54. 